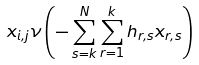Convert formula to latex. <formula><loc_0><loc_0><loc_500><loc_500>x _ { i , j } \nu \left ( - \sum _ { s = k } ^ { N } \sum _ { r = 1 } ^ { k } h _ { r , s } x _ { r , s } \right )</formula> 